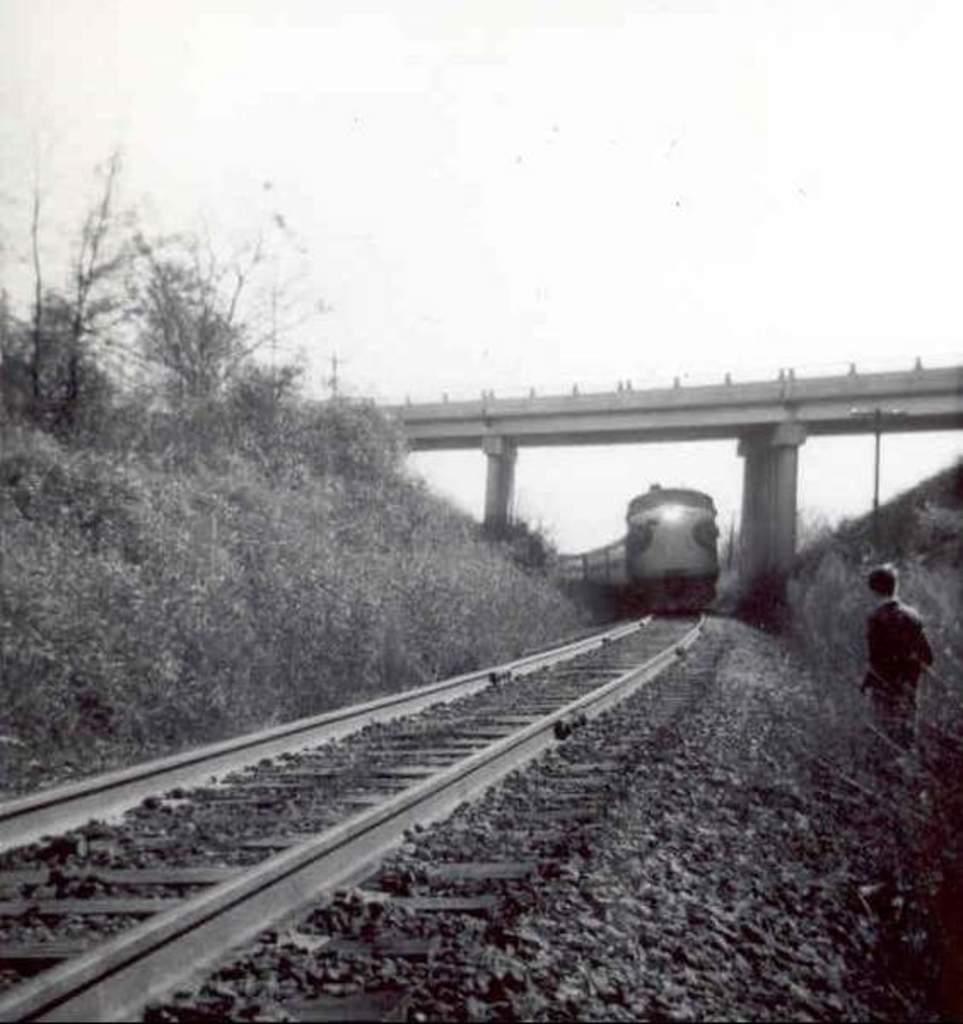Can you describe this image briefly? In this picture we can observe a train on the railway track. We can observe some stones. On the right side there are some plants on either sides of the track. In the background there is a bridge in the sky. This is a black and white image. 